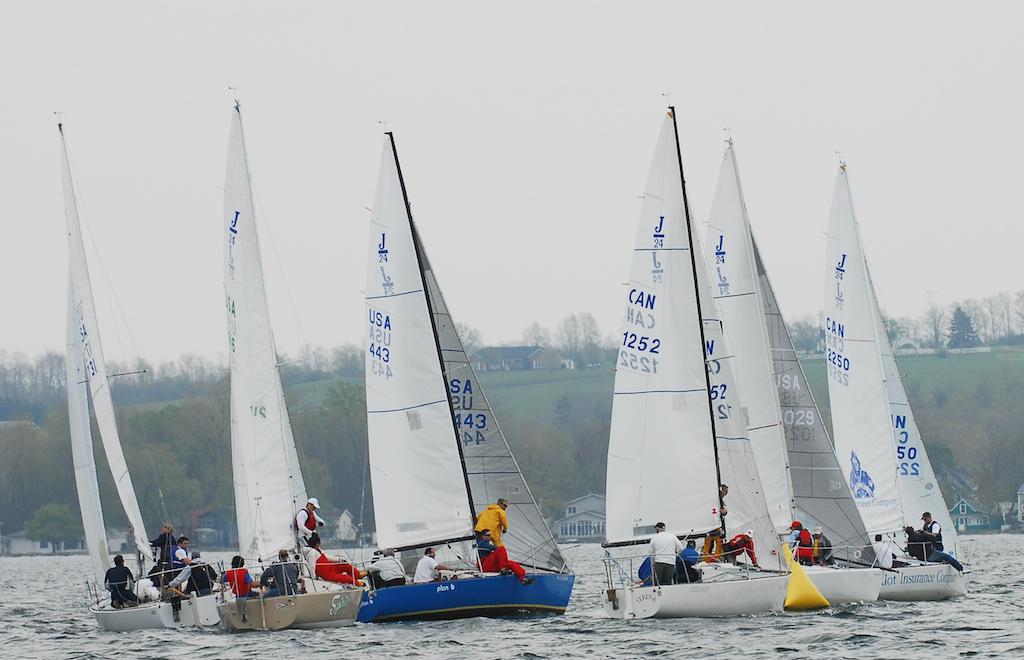What country is the blue sailboat from?
Provide a short and direct response. Usa. What country is to the right of the blue sailboat?
Provide a succinct answer. Canada. 